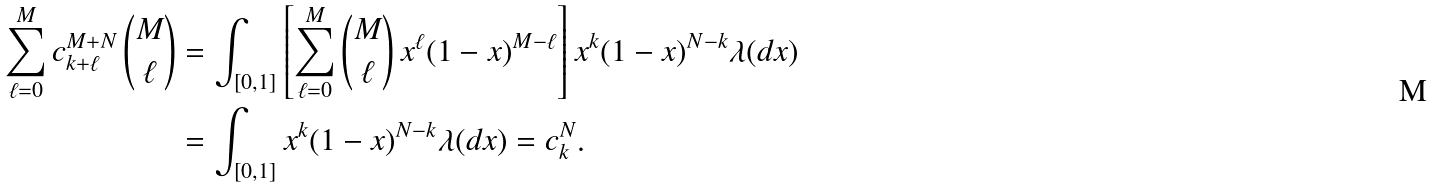<formula> <loc_0><loc_0><loc_500><loc_500>\sum _ { \ell = 0 } ^ { M } c ^ { M + N } _ { k + \ell } \, \binom { M } { \ell } & = \int _ { [ 0 , 1 ] } \left [ \sum _ { \ell = 0 } ^ { M } \binom { M } { \ell } \, x ^ { \ell } ( 1 - x ) ^ { M - \ell } \right ] x ^ { k } ( 1 - x ) ^ { N - k } \lambda ( d x ) \\ & = \int _ { [ 0 , 1 ] } x ^ { k } ( 1 - x ) ^ { N - k } \lambda ( d x ) = c ^ { N } _ { k } .</formula> 